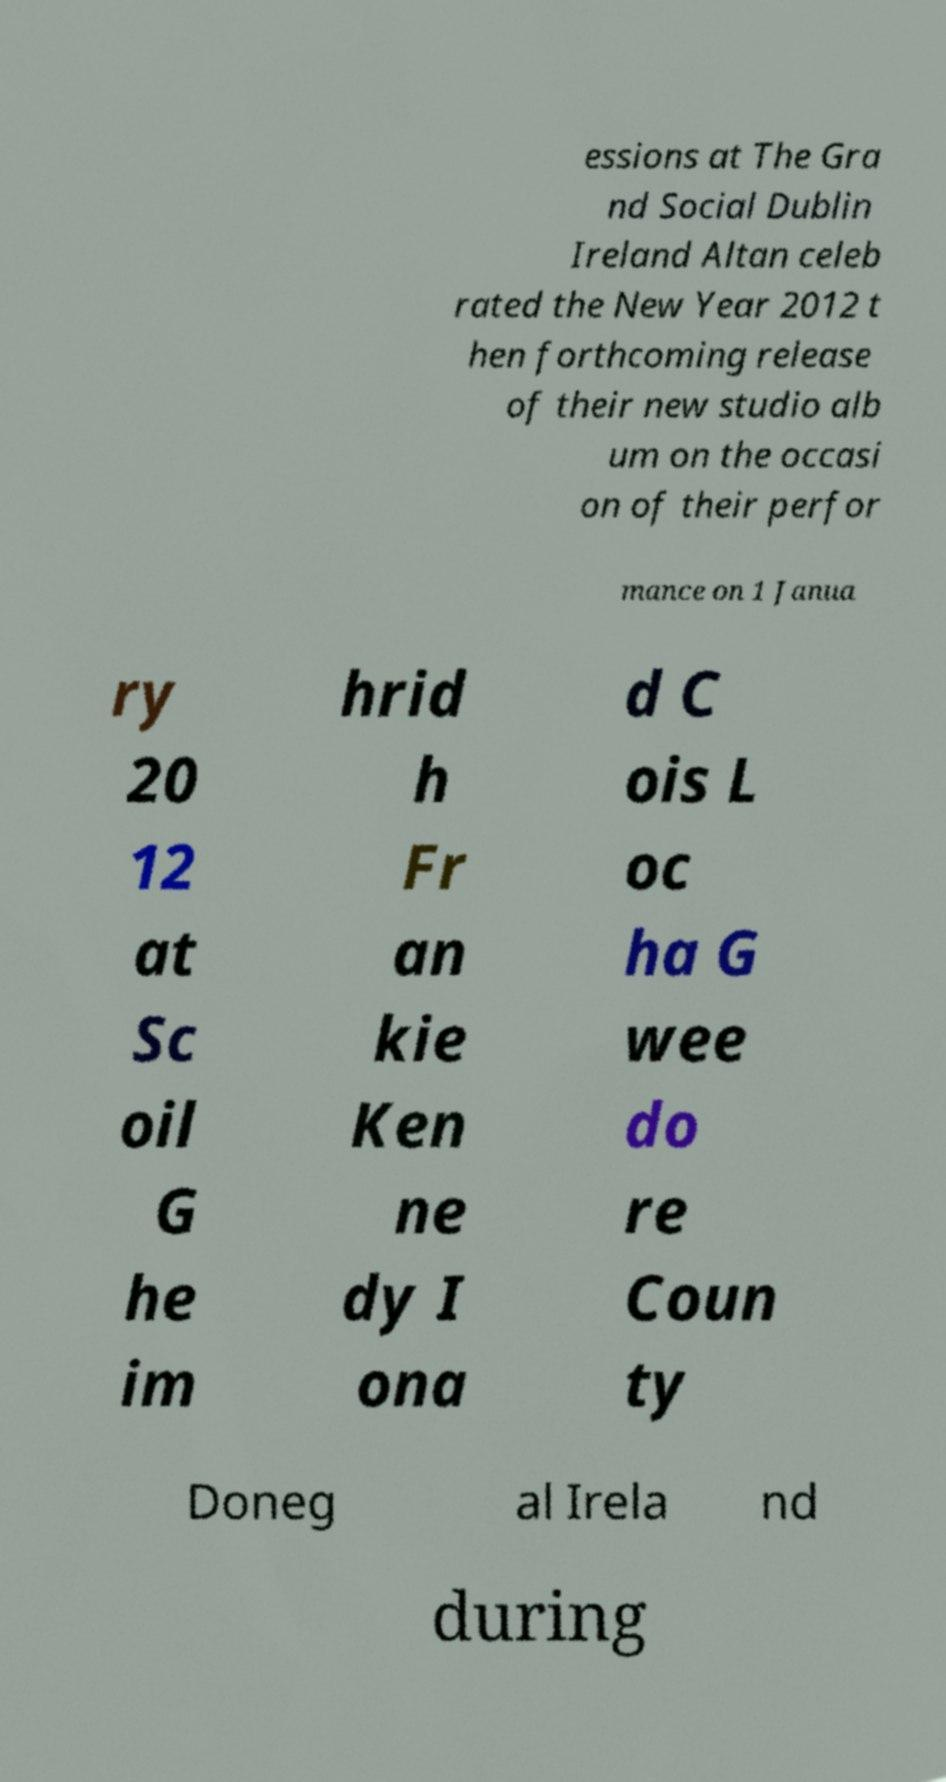What messages or text are displayed in this image? I need them in a readable, typed format. essions at The Gra nd Social Dublin Ireland Altan celeb rated the New Year 2012 t hen forthcoming release of their new studio alb um on the occasi on of their perfor mance on 1 Janua ry 20 12 at Sc oil G he im hrid h Fr an kie Ken ne dy I ona d C ois L oc ha G wee do re Coun ty Doneg al Irela nd during 